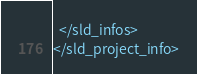<code> <loc_0><loc_0><loc_500><loc_500><_Scheme_>  </sld_infos>
</sld_project_info>
</code> 